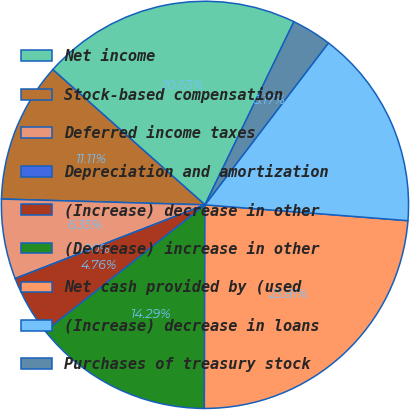<chart> <loc_0><loc_0><loc_500><loc_500><pie_chart><fcel>Net income<fcel>Stock-based compensation<fcel>Deferred income taxes<fcel>Depreciation and amortization<fcel>(Increase) decrease in other<fcel>(Decrease) increase in other<fcel>Net cash provided by (used<fcel>(Increase) decrease in loans<fcel>Purchases of treasury stock<nl><fcel>20.63%<fcel>11.11%<fcel>6.35%<fcel>0.0%<fcel>4.76%<fcel>14.29%<fcel>23.81%<fcel>15.87%<fcel>3.17%<nl></chart> 